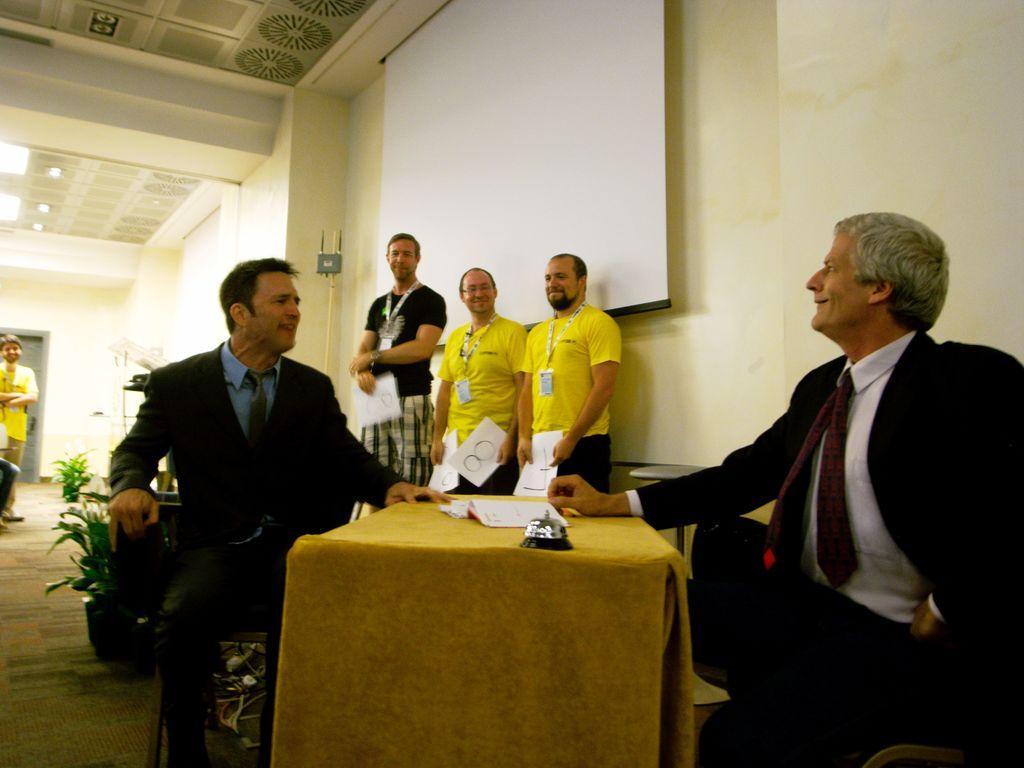Can you describe this image briefly? In this picture there are two people sitting. They both are wearing black jacket. In between there is a table with papers and bell on it. Beside there are three men. Two men are wearing yellow t-shirt. And the other is wearing a black t-shirt. On the wall there is a screen. To the left there is a man with yellow color t-shirt is standing. On the top there are lights. 